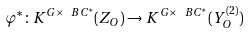Convert formula to latex. <formula><loc_0><loc_0><loc_500><loc_500>\varphi ^ { * } \colon K ^ { G \times \ B C ^ { * } } ( Z _ { O } ) \to K ^ { G \times \ B C ^ { * } } ( Y _ { O } ^ { ( 2 ) } )</formula> 